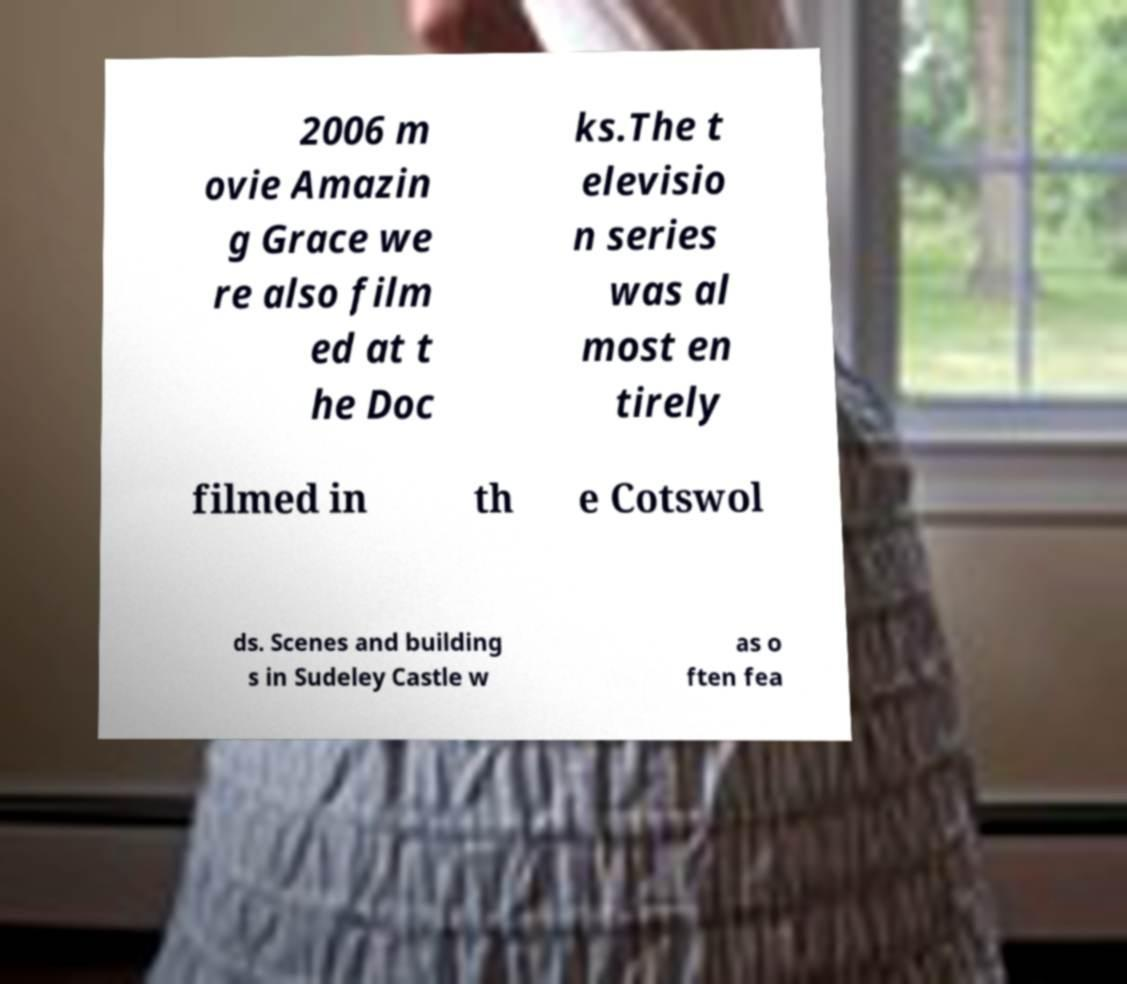What messages or text are displayed in this image? I need them in a readable, typed format. 2006 m ovie Amazin g Grace we re also film ed at t he Doc ks.The t elevisio n series was al most en tirely filmed in th e Cotswol ds. Scenes and building s in Sudeley Castle w as o ften fea 